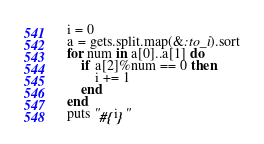<code> <loc_0><loc_0><loc_500><loc_500><_Ruby_>i = 0
a = gets.split.map(&:to_i).sort
for num in a[0]..a[1] do
	if a[2]%num == 0 then
		i += 1
	end
end
puts "#{i}"</code> 